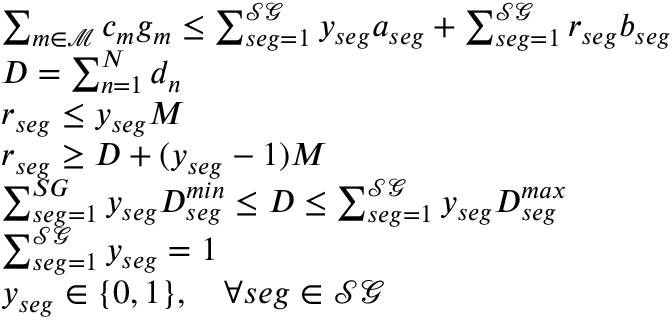<formula> <loc_0><loc_0><loc_500><loc_500>\begin{array} { r l } & { \sum _ { m \in \mathcal { M } } c _ { m } g _ { m } \leq \sum _ { s e g = 1 } ^ { \mathcal { S G } } y _ { s e g } a _ { s e g } + \sum _ { s e g = 1 } ^ { \mathcal { S G } } r _ { s e g } b _ { s e g } } \\ & { D = \sum _ { n = 1 } ^ { N } d _ { n } } \\ & { r _ { s e g } \leq y _ { s e g } M } \\ & { r _ { s e g } \geq D + ( y _ { s e g } - 1 ) M } \\ & { \sum _ { s e g = 1 } ^ { S G } y _ { s e g } D _ { s e g } ^ { \min } \leq D \leq \sum _ { s e g = 1 } ^ { \mathcal { S G } } y _ { s e g } D _ { s e g } ^ { \max } } \\ & { \sum _ { s e g = 1 } ^ { \mathcal { S G } } y _ { s e g } = 1 } \\ & { y _ { s e g } \in \{ 0 , 1 \} , \quad \forall s e g \in \mathcal { S G } } \end{array}</formula> 